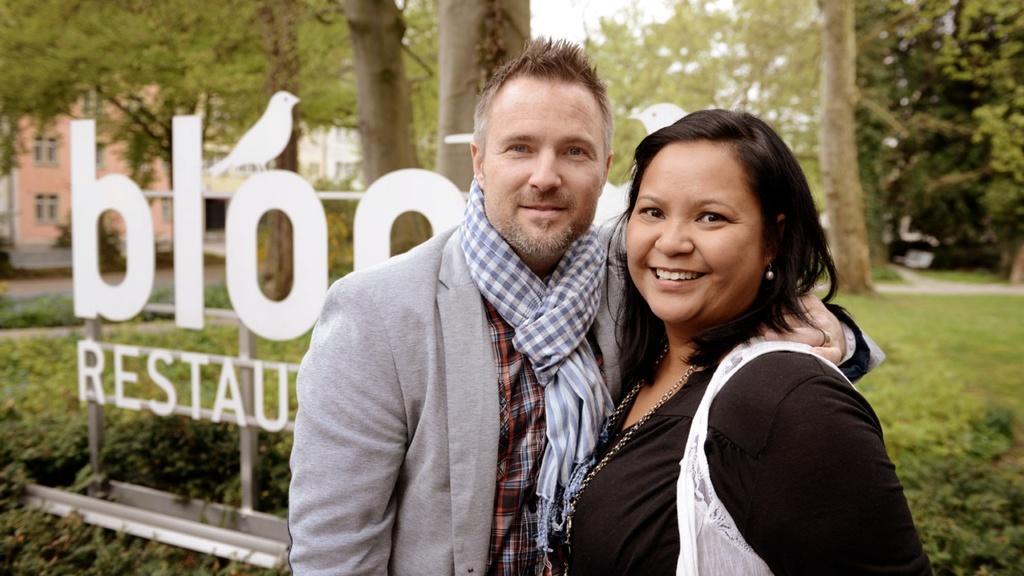In one or two sentences, can you explain what this image depicts? In this image there is a man and a woman standing with a smile on their face, behind them there is a logo of a restaurant, behind that there is grass, behind the grass there are trees and a building. 